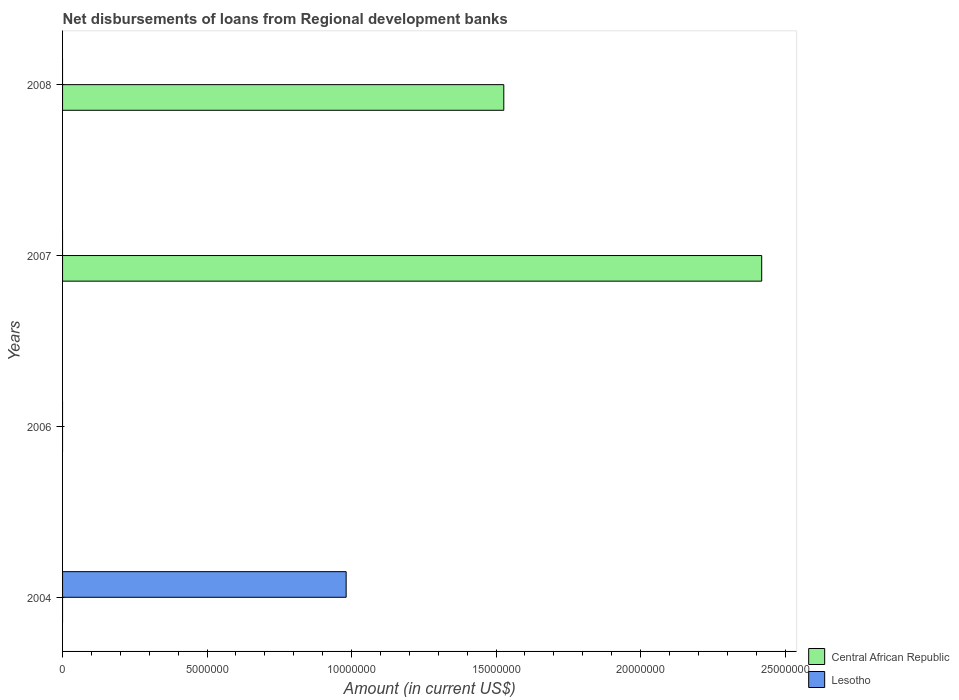How many different coloured bars are there?
Keep it short and to the point. 2. Are the number of bars per tick equal to the number of legend labels?
Ensure brevity in your answer.  No. Are the number of bars on each tick of the Y-axis equal?
Your answer should be very brief. No. How many bars are there on the 3rd tick from the top?
Provide a short and direct response. 0. What is the label of the 4th group of bars from the top?
Provide a succinct answer. 2004. In how many cases, is the number of bars for a given year not equal to the number of legend labels?
Keep it short and to the point. 4. What is the amount of disbursements of loans from regional development banks in Central African Republic in 2008?
Give a very brief answer. 1.53e+07. Across all years, what is the maximum amount of disbursements of loans from regional development banks in Central African Republic?
Give a very brief answer. 2.42e+07. What is the total amount of disbursements of loans from regional development banks in Lesotho in the graph?
Make the answer very short. 9.81e+06. What is the difference between the amount of disbursements of loans from regional development banks in Central African Republic in 2007 and that in 2008?
Ensure brevity in your answer.  8.92e+06. What is the difference between the amount of disbursements of loans from regional development banks in Central African Republic in 2004 and the amount of disbursements of loans from regional development banks in Lesotho in 2008?
Your answer should be compact. 0. What is the average amount of disbursements of loans from regional development banks in Lesotho per year?
Offer a terse response. 2.45e+06. In how many years, is the amount of disbursements of loans from regional development banks in Lesotho greater than 15000000 US$?
Your response must be concise. 0. Is the amount of disbursements of loans from regional development banks in Central African Republic in 2007 less than that in 2008?
Keep it short and to the point. No. What is the difference between the highest and the lowest amount of disbursements of loans from regional development banks in Central African Republic?
Give a very brief answer. 2.42e+07. How are the legend labels stacked?
Provide a short and direct response. Vertical. What is the title of the graph?
Keep it short and to the point. Net disbursements of loans from Regional development banks. What is the label or title of the X-axis?
Keep it short and to the point. Amount (in current US$). What is the Amount (in current US$) of Lesotho in 2004?
Ensure brevity in your answer.  9.81e+06. What is the Amount (in current US$) of Central African Republic in 2006?
Make the answer very short. 0. What is the Amount (in current US$) in Lesotho in 2006?
Keep it short and to the point. 0. What is the Amount (in current US$) in Central African Republic in 2007?
Provide a succinct answer. 2.42e+07. What is the Amount (in current US$) of Central African Republic in 2008?
Your response must be concise. 1.53e+07. What is the Amount (in current US$) of Lesotho in 2008?
Your answer should be very brief. 0. Across all years, what is the maximum Amount (in current US$) of Central African Republic?
Offer a very short reply. 2.42e+07. Across all years, what is the maximum Amount (in current US$) in Lesotho?
Ensure brevity in your answer.  9.81e+06. What is the total Amount (in current US$) in Central African Republic in the graph?
Offer a terse response. 3.95e+07. What is the total Amount (in current US$) in Lesotho in the graph?
Keep it short and to the point. 9.81e+06. What is the difference between the Amount (in current US$) in Central African Republic in 2007 and that in 2008?
Provide a short and direct response. 8.92e+06. What is the average Amount (in current US$) in Central African Republic per year?
Keep it short and to the point. 9.87e+06. What is the average Amount (in current US$) in Lesotho per year?
Keep it short and to the point. 2.45e+06. What is the ratio of the Amount (in current US$) of Central African Republic in 2007 to that in 2008?
Ensure brevity in your answer.  1.58. What is the difference between the highest and the lowest Amount (in current US$) of Central African Republic?
Offer a terse response. 2.42e+07. What is the difference between the highest and the lowest Amount (in current US$) of Lesotho?
Provide a short and direct response. 9.81e+06. 